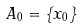<formula> <loc_0><loc_0><loc_500><loc_500>A _ { 0 } = \left \{ x _ { 0 } \right \}</formula> 